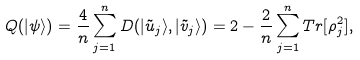Convert formula to latex. <formula><loc_0><loc_0><loc_500><loc_500>Q ( | \psi \rangle ) = \frac { 4 } { n } \sum ^ { n } _ { j = 1 } D ( | \tilde { u } _ { j } \rangle , | \tilde { v } _ { j } \rangle ) = 2 - \frac { 2 } { n } \sum ^ { n } _ { j = 1 } T r [ \rho _ { j } ^ { 2 } ] ,</formula> 